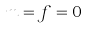<formula> <loc_0><loc_0><loc_500><loc_500>m = f = 0</formula> 